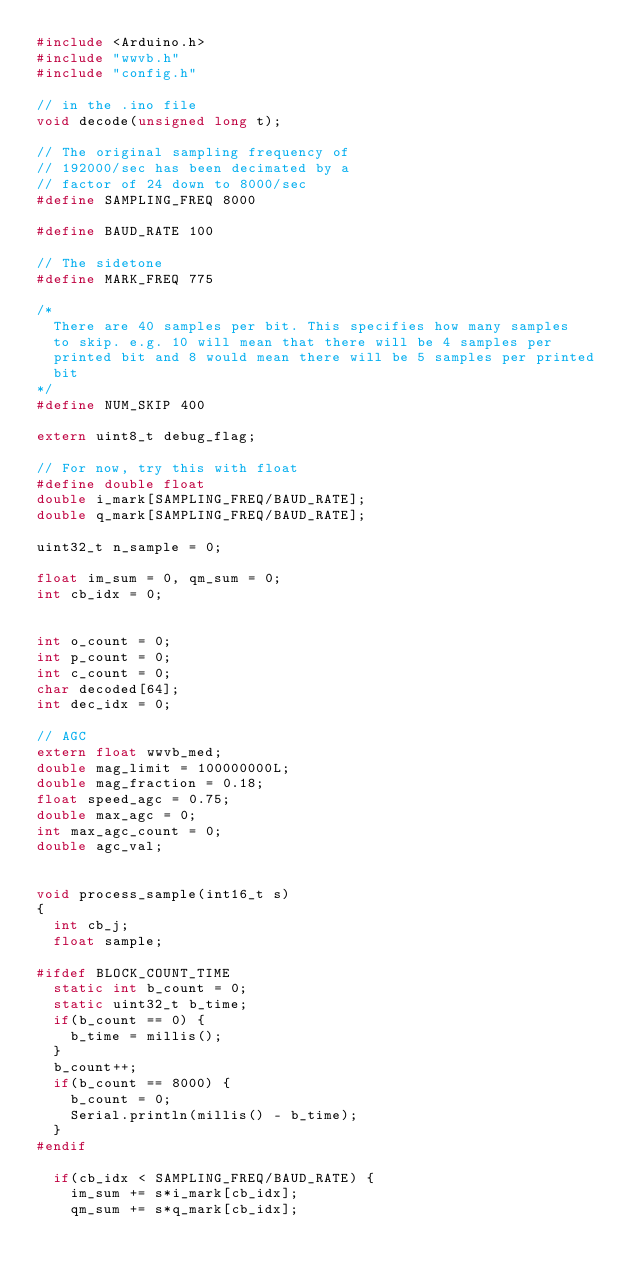Convert code to text. <code><loc_0><loc_0><loc_500><loc_500><_C++_>#include <Arduino.h>
#include "wwvb.h"
#include "config.h"

// in the .ino file
void decode(unsigned long t);

// The original sampling frequency of
// 192000/sec has been decimated by a
// factor of 24 down to 8000/sec
#define SAMPLING_FREQ 8000

#define BAUD_RATE 100

// The sidetone
#define MARK_FREQ 775

/*
  There are 40 samples per bit. This specifies how many samples
  to skip. e.g. 10 will mean that there will be 4 samples per
  printed bit and 8 would mean there will be 5 samples per printed
  bit
*/
#define NUM_SKIP 400

extern uint8_t debug_flag;

// For now, try this with float
#define double float
double i_mark[SAMPLING_FREQ/BAUD_RATE];
double q_mark[SAMPLING_FREQ/BAUD_RATE];

uint32_t n_sample = 0;

float im_sum = 0, qm_sum = 0;
int cb_idx = 0;


int o_count = 0;
int p_count = 0;
int c_count = 0;
char decoded[64];
int dec_idx = 0;

// AGC
extern float wwvb_med;
double mag_limit = 100000000L;
double mag_fraction = 0.18;
float speed_agc = 0.75;
double max_agc = 0;
int max_agc_count = 0;
double agc_val;


void process_sample(int16_t s)
{
  int cb_j;
  float sample;

#ifdef BLOCK_COUNT_TIME
  static int b_count = 0;
  static uint32_t b_time;
  if(b_count == 0) {
    b_time = millis();
  }
  b_count++;
  if(b_count == 8000) {
    b_count = 0;
    Serial.println(millis() - b_time);
  }
#endif

  if(cb_idx < SAMPLING_FREQ/BAUD_RATE) {
    im_sum += s*i_mark[cb_idx];
    qm_sum += s*q_mark[cb_idx];</code> 